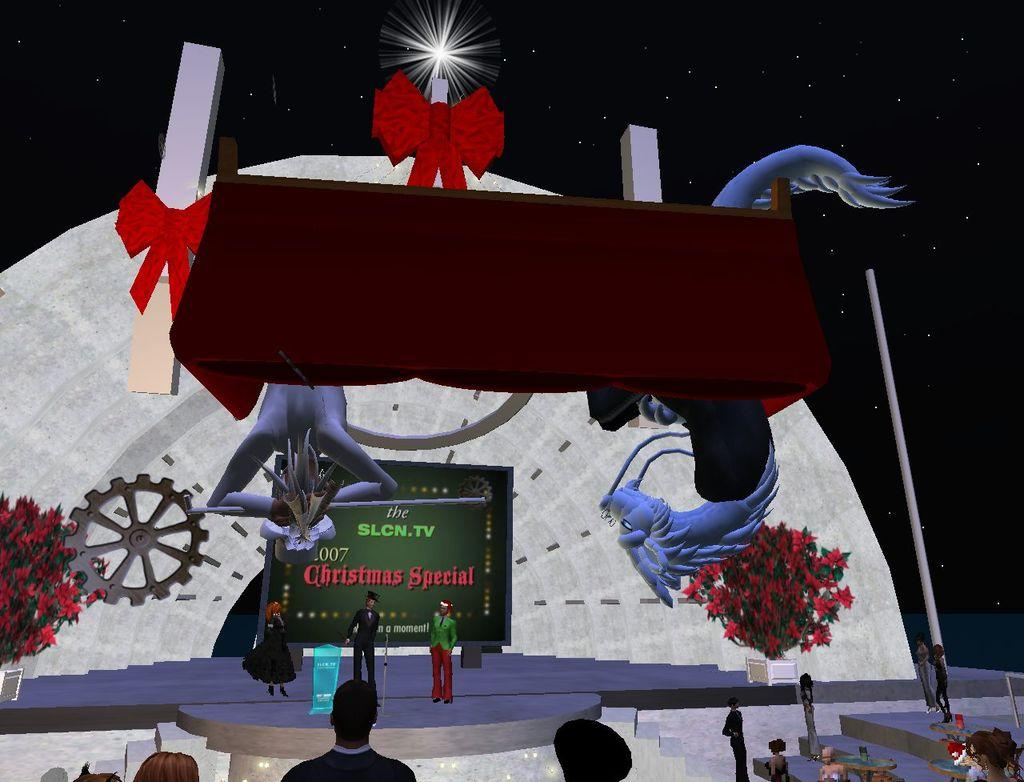What type of image can be seen in the picture? There is a graphical image in the picture. What else is present in the picture besides the graphical image? There is a board with text and people standing in the picture. Are there any natural elements visible in the picture? Yes, there are plants with flowers in the picture. What can be seen in the sky in the picture? There are stars visible in the sky. What type of fang can be seen in the picture? There is no fang present in the picture. What poisonous substance is mentioned in the text on the board? The text on the board does not mention any poisonous substances. 